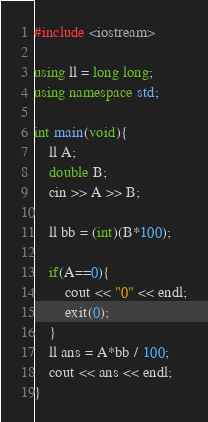<code> <loc_0><loc_0><loc_500><loc_500><_C++_>#include <iostream>

using ll = long long;
using namespace std;

int main(void){
    ll A;
    double B;
    cin >> A >> B;
    
    ll bb = (int)(B*100);
    
    if(A==0){
        cout << "0" << endl;
        exit(0);
    }
    ll ans = A*bb / 100;
    cout << ans << endl;
}</code> 